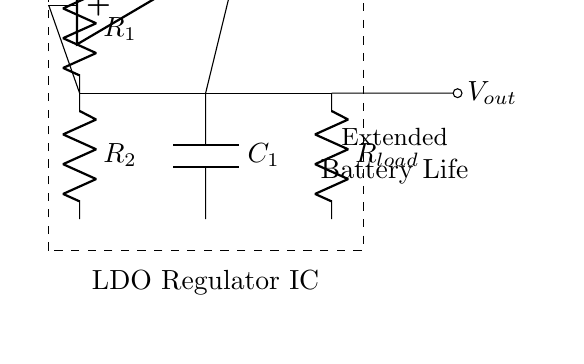What is the input voltage in this circuit? The input voltage is labeled as V_in, which is indicated at the top of the battery symbol in the circuit.
Answer: V_in What type of regulation does this circuit provide? The circuit is specifically designed as a low-dropout regulator, as stated in the description on the diagram.
Answer: Low-dropout How many resistors are present in the circuit? There are two resistors labeled as R_1 and R_2, both of which are connected in the circuit as indicated by the labels.
Answer: 2 What does C_1 in the circuit represent? C_1 is labeled as a capacitor, and it is connected at a specific point to stabilize the output voltage.
Answer: Capacitor What is the function of the operational amplifier in this circuit? The operational amplifier regulates the output voltage by comparing the output voltage with a reference voltage and controlling the output.
Answer: Regulator What is indicated by the dashed rectangle in the diagram? The dashed rectangle encapsulates the entire low-dropout regulator circuit, indicating its functional boundaries as a component.
Answer: LDO Regulator IC What component is connected to V_out? R_load is connected to the output voltage V_out, providing the load which consumes the regulated voltage.
Answer: R_load 